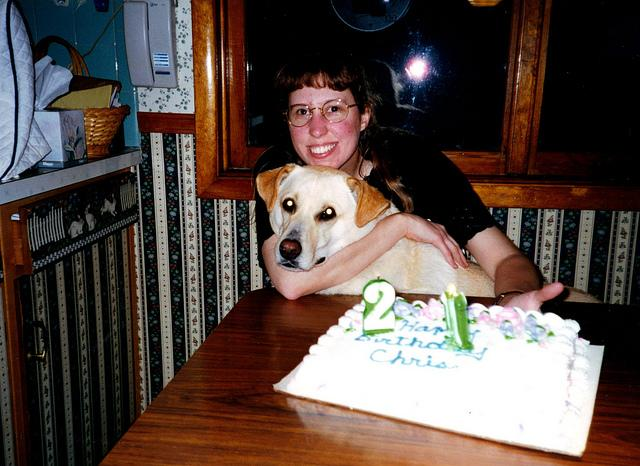Where is the dog sitting? Please explain your reasoning. girls lap. The dog is sitting on the woman's lap. the dog is being held. 